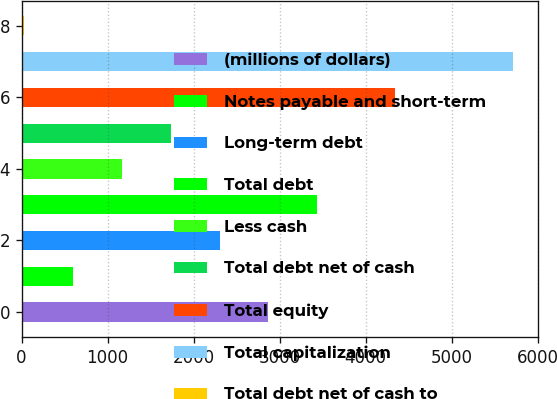Convert chart to OTSL. <chart><loc_0><loc_0><loc_500><loc_500><bar_chart><fcel>(millions of dollars)<fcel>Notes payable and short-term<fcel>Long-term debt<fcel>Total debt<fcel>Less cash<fcel>Total debt net of cash<fcel>Total equity<fcel>Total capitalization<fcel>Total debt net of cash to<nl><fcel>2871.35<fcel>593.47<fcel>2301.88<fcel>3440.82<fcel>1162.94<fcel>1732.41<fcel>4344.8<fcel>5718.7<fcel>24<nl></chart> 